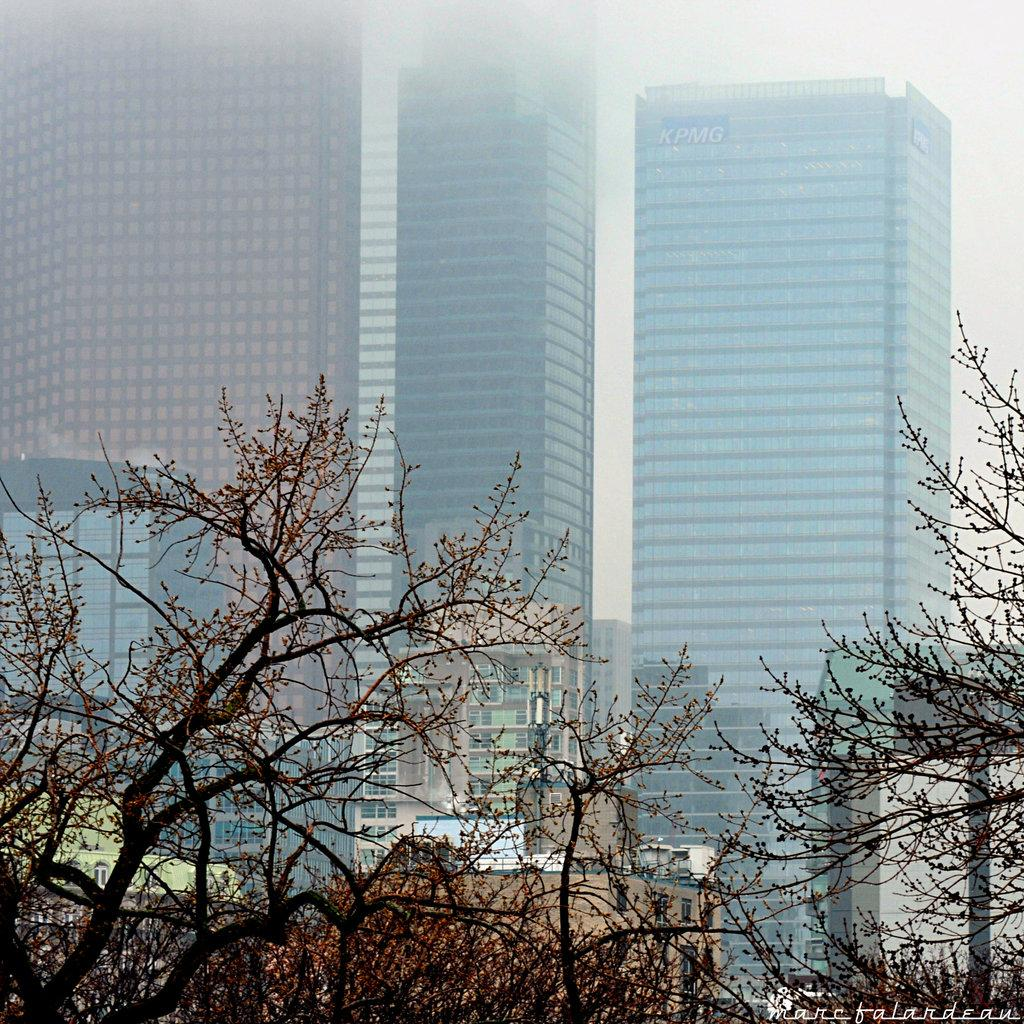What type of natural elements can be seen in the image? There are trees in the image. What type of man-made structures are visible in the background of the image? There are tower buildings in the background of the image. What type of toys can be seen in the advertisement in the image? There is no advertisement present in the image, so it is not possible to determine what toys might be featured in an advertisement. 